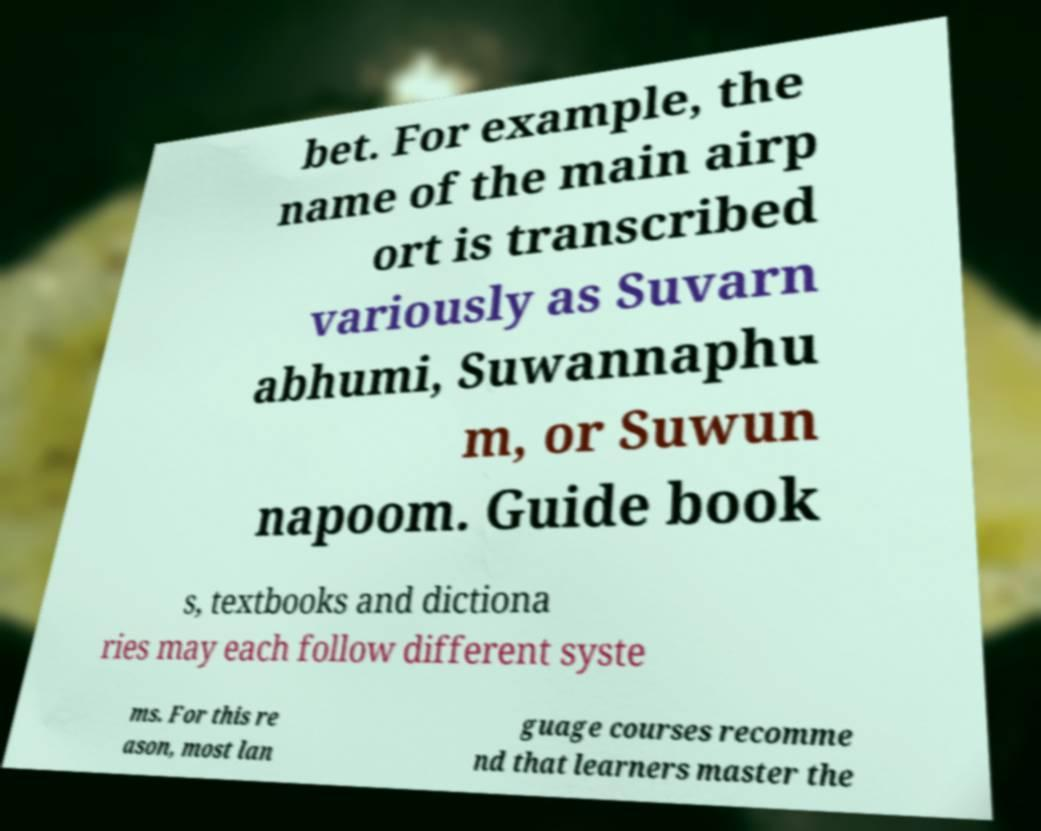For documentation purposes, I need the text within this image transcribed. Could you provide that? bet. For example, the name of the main airp ort is transcribed variously as Suvarn abhumi, Suwannaphu m, or Suwun napoom. Guide book s, textbooks and dictiona ries may each follow different syste ms. For this re ason, most lan guage courses recomme nd that learners master the 